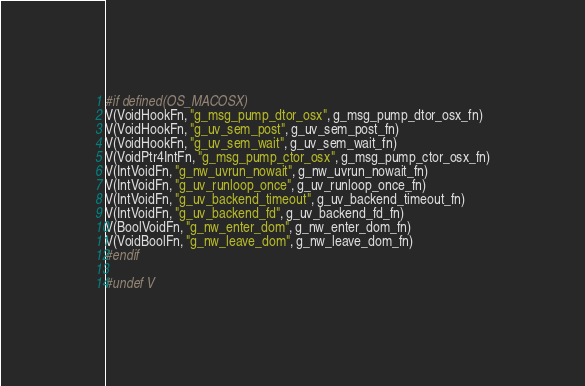Convert code to text. <code><loc_0><loc_0><loc_500><loc_500><_C_>
#if defined(OS_MACOSX)
V(VoidHookFn, "g_msg_pump_dtor_osx", g_msg_pump_dtor_osx_fn)
V(VoidHookFn, "g_uv_sem_post", g_uv_sem_post_fn)
V(VoidHookFn, "g_uv_sem_wait", g_uv_sem_wait_fn)
V(VoidPtr4IntFn, "g_msg_pump_ctor_osx", g_msg_pump_ctor_osx_fn)
V(IntVoidFn, "g_nw_uvrun_nowait", g_nw_uvrun_nowait_fn)
V(IntVoidFn, "g_uv_runloop_once", g_uv_runloop_once_fn)
V(IntVoidFn, "g_uv_backend_timeout", g_uv_backend_timeout_fn)
V(IntVoidFn, "g_uv_backend_fd", g_uv_backend_fd_fn)
V(BoolVoidFn, "g_nw_enter_dom", g_nw_enter_dom_fn)
V(VoidBoolFn, "g_nw_leave_dom", g_nw_leave_dom_fn)
#endif

#undef V
</code> 